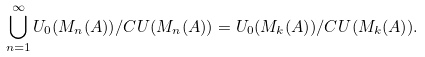<formula> <loc_0><loc_0><loc_500><loc_500>\bigcup _ { n = 1 } ^ { \infty } U _ { 0 } ( M _ { n } ( A ) ) / C U ( M _ { n } ( A ) ) = U _ { 0 } ( M _ { k } ( A ) ) / C U ( M _ { k } ( A ) ) .</formula> 